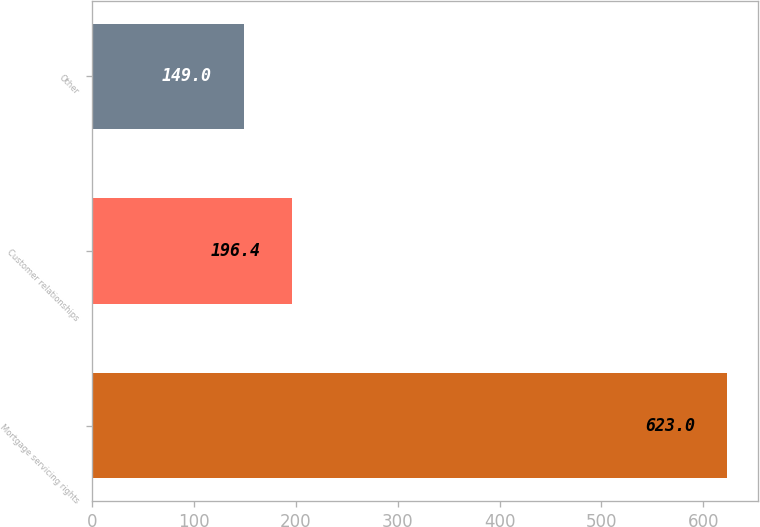<chart> <loc_0><loc_0><loc_500><loc_500><bar_chart><fcel>Mortgage servicing rights<fcel>Customer relationships<fcel>Other<nl><fcel>623<fcel>196.4<fcel>149<nl></chart> 